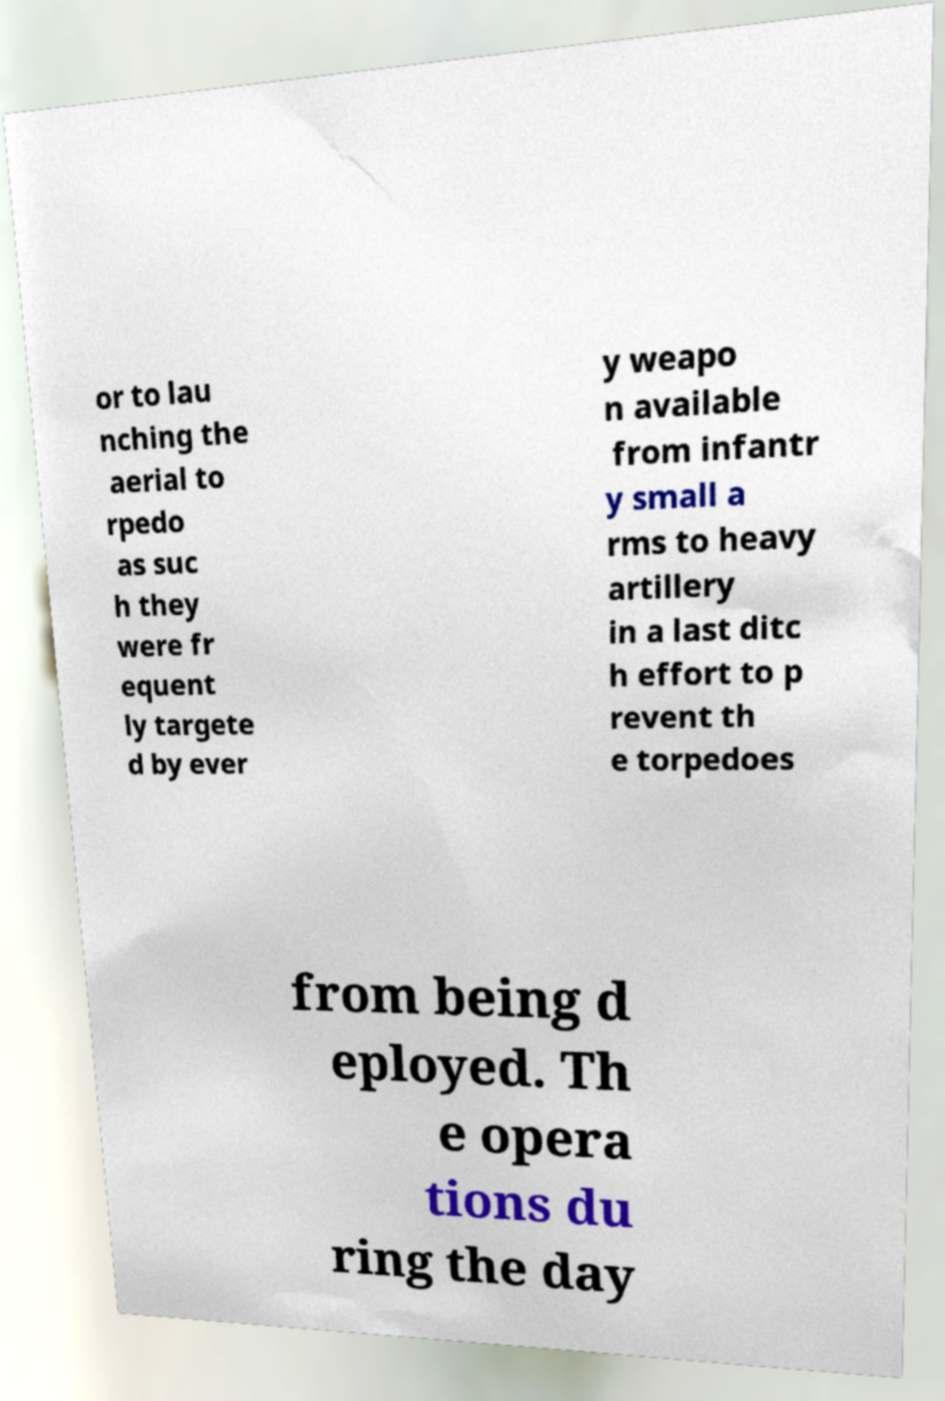Could you assist in decoding the text presented in this image and type it out clearly? or to lau nching the aerial to rpedo as suc h they were fr equent ly targete d by ever y weapo n available from infantr y small a rms to heavy artillery in a last ditc h effort to p revent th e torpedoes from being d eployed. Th e opera tions du ring the day 